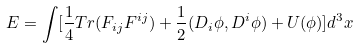Convert formula to latex. <formula><loc_0><loc_0><loc_500><loc_500>E = \int [ \frac { 1 } { 4 } T r ( F _ { i j } F ^ { i j } ) + \frac { 1 } { 2 } ( D _ { i } \phi , D ^ { i } \phi ) + U ( \phi ) ] d ^ { 3 } x</formula> 